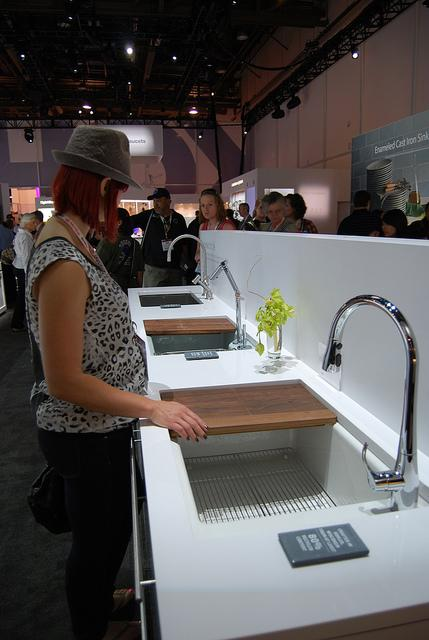If this person wanted to wash their hands where would they have to go?

Choices:
A) here
B) gas station
C) bathroom
D) kitchen bathroom 